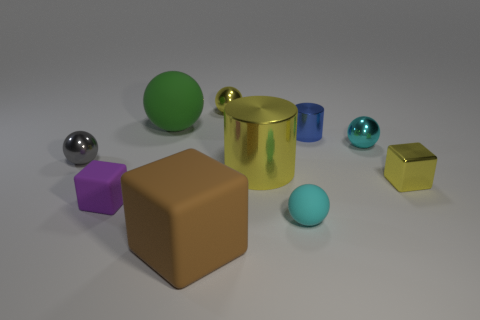Is the color of the small cube that is to the right of the large rubber cube the same as the big metallic cylinder?
Your response must be concise. Yes. What is the shape of the tiny thing that is both to the left of the big ball and in front of the tiny gray object?
Make the answer very short. Cube. The cylinder that is behind the big yellow shiny thing is what color?
Ensure brevity in your answer.  Blue. Is there any other thing that is the same color as the big metallic thing?
Ensure brevity in your answer.  Yes. Is the blue cylinder the same size as the green object?
Offer a very short reply. No. What size is the yellow metal thing that is in front of the green rubber sphere and left of the cyan matte sphere?
Ensure brevity in your answer.  Large. How many yellow balls are the same material as the yellow cylinder?
Your answer should be compact. 1. There is a large thing that is the same color as the shiny cube; what shape is it?
Provide a short and direct response. Cylinder. The big metal cylinder has what color?
Keep it short and to the point. Yellow. Do the thing to the left of the purple thing and the green thing have the same shape?
Your answer should be very brief. Yes. 